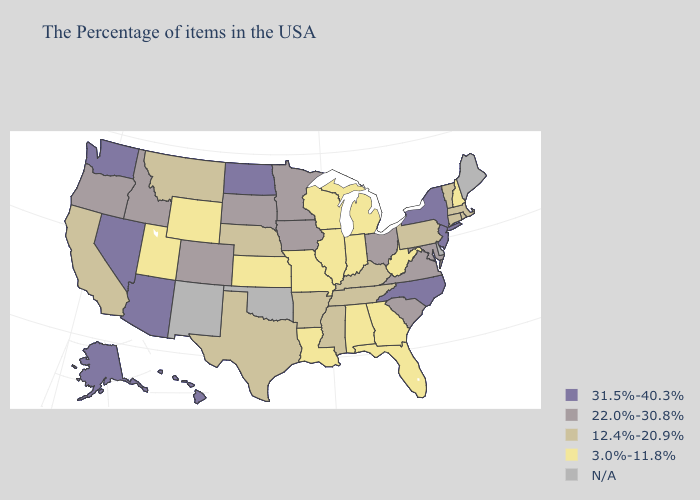What is the lowest value in the Northeast?
Answer briefly. 3.0%-11.8%. Name the states that have a value in the range 22.0%-30.8%?
Give a very brief answer. Maryland, Virginia, South Carolina, Ohio, Minnesota, Iowa, South Dakota, Colorado, Idaho, Oregon. Among the states that border South Dakota , does Iowa have the lowest value?
Write a very short answer. No. Among the states that border Wisconsin , does Minnesota have the lowest value?
Concise answer only. No. Does the first symbol in the legend represent the smallest category?
Keep it brief. No. Does Arizona have the highest value in the USA?
Answer briefly. Yes. Name the states that have a value in the range 31.5%-40.3%?
Write a very short answer. New York, New Jersey, North Carolina, North Dakota, Arizona, Nevada, Washington, Alaska, Hawaii. Name the states that have a value in the range 12.4%-20.9%?
Concise answer only. Massachusetts, Rhode Island, Vermont, Connecticut, Pennsylvania, Kentucky, Tennessee, Mississippi, Arkansas, Nebraska, Texas, Montana, California. What is the highest value in the South ?
Be succinct. 31.5%-40.3%. Name the states that have a value in the range 22.0%-30.8%?
Give a very brief answer. Maryland, Virginia, South Carolina, Ohio, Minnesota, Iowa, South Dakota, Colorado, Idaho, Oregon. What is the value of Oklahoma?
Keep it brief. N/A. What is the highest value in states that border Kansas?
Quick response, please. 22.0%-30.8%. What is the highest value in states that border Arkansas?
Quick response, please. 12.4%-20.9%. What is the lowest value in the USA?
Write a very short answer. 3.0%-11.8%. Does North Dakota have the highest value in the USA?
Write a very short answer. Yes. 